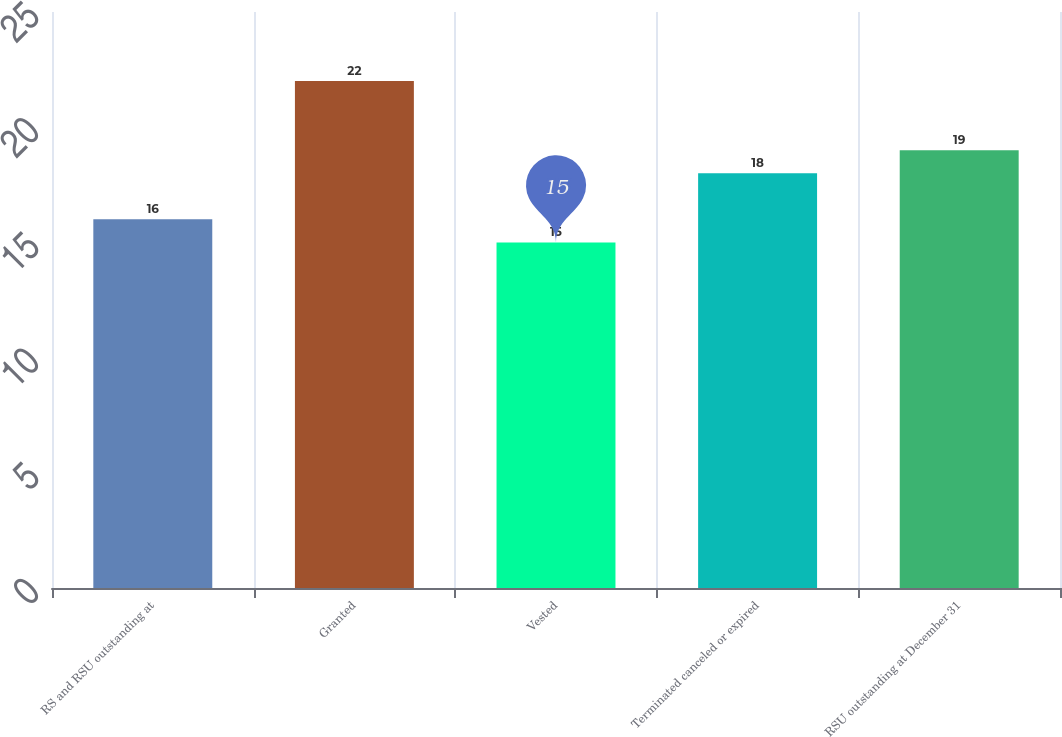Convert chart to OTSL. <chart><loc_0><loc_0><loc_500><loc_500><bar_chart><fcel>RS and RSU outstanding at<fcel>Granted<fcel>Vested<fcel>Terminated canceled or expired<fcel>RSU outstanding at December 31<nl><fcel>16<fcel>22<fcel>15<fcel>18<fcel>19<nl></chart> 